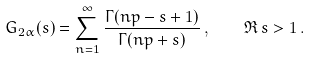Convert formula to latex. <formula><loc_0><loc_0><loc_500><loc_500>G _ { 2 \alpha } ( s ) = \sum _ { n = 1 } ^ { \infty } \frac { \Gamma ( n p - s + 1 ) } { \Gamma ( n p + s ) } \, , \quad \Re \, s > 1 \, .</formula> 